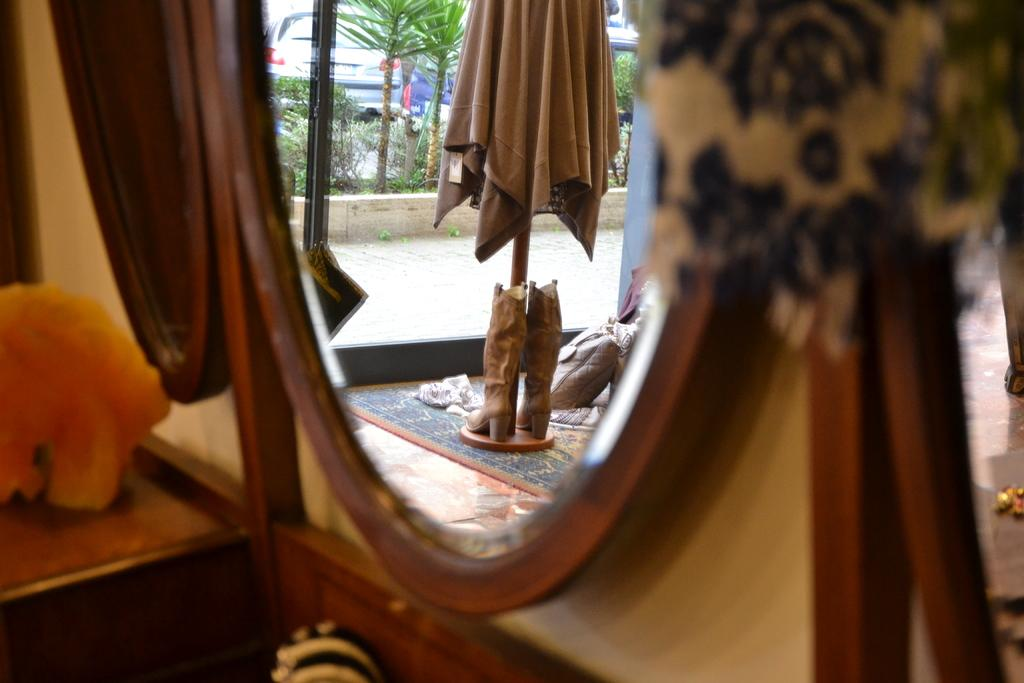What object in the image reflects its surroundings? There is a mirror in the image that reflects its surroundings. What does the mirror reflect in the image? The mirror reflects a statue, trees, vehicles, and a road in the image. Where is the wooden table located in the image? The wooden table is on the left side of the image. How does the mirror increase the size of the statue in the image? The mirror does not increase the size of the statue in the image; it simply reflects the statue as it is. Is there a volcano visible in the image? No, there is no volcano present in the image. 